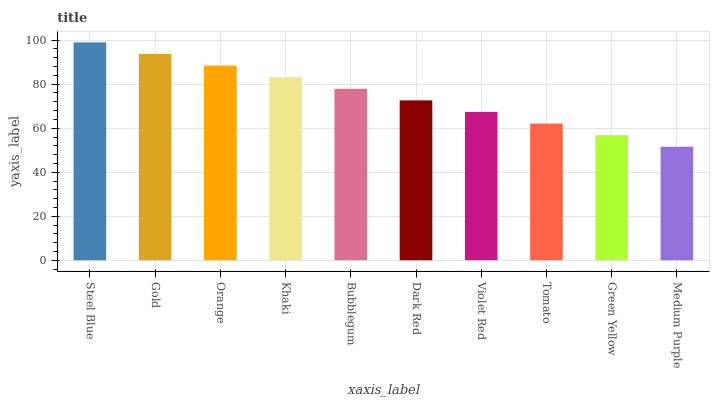Is Medium Purple the minimum?
Answer yes or no. Yes. Is Steel Blue the maximum?
Answer yes or no. Yes. Is Gold the minimum?
Answer yes or no. No. Is Gold the maximum?
Answer yes or no. No. Is Steel Blue greater than Gold?
Answer yes or no. Yes. Is Gold less than Steel Blue?
Answer yes or no. Yes. Is Gold greater than Steel Blue?
Answer yes or no. No. Is Steel Blue less than Gold?
Answer yes or no. No. Is Bubblegum the high median?
Answer yes or no. Yes. Is Dark Red the low median?
Answer yes or no. Yes. Is Gold the high median?
Answer yes or no. No. Is Steel Blue the low median?
Answer yes or no. No. 